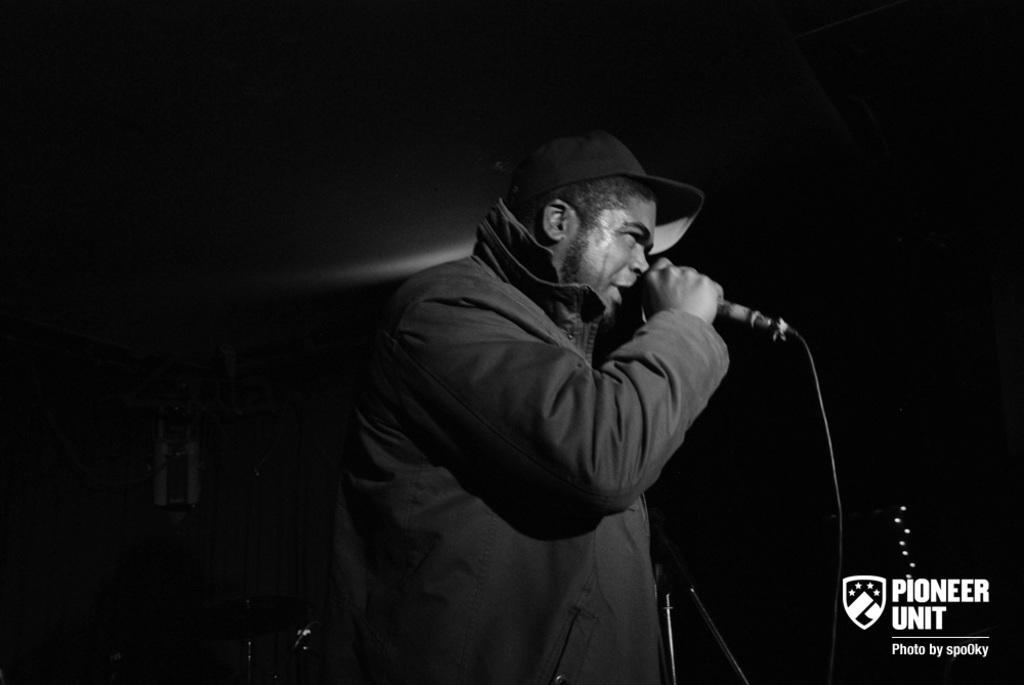Can you describe this image briefly? Background of the picture is very dark. in this picture we can see a man wearing a jacket and standing and singing something by holding a mike in his hand. He wore a cap which is in black colour. 